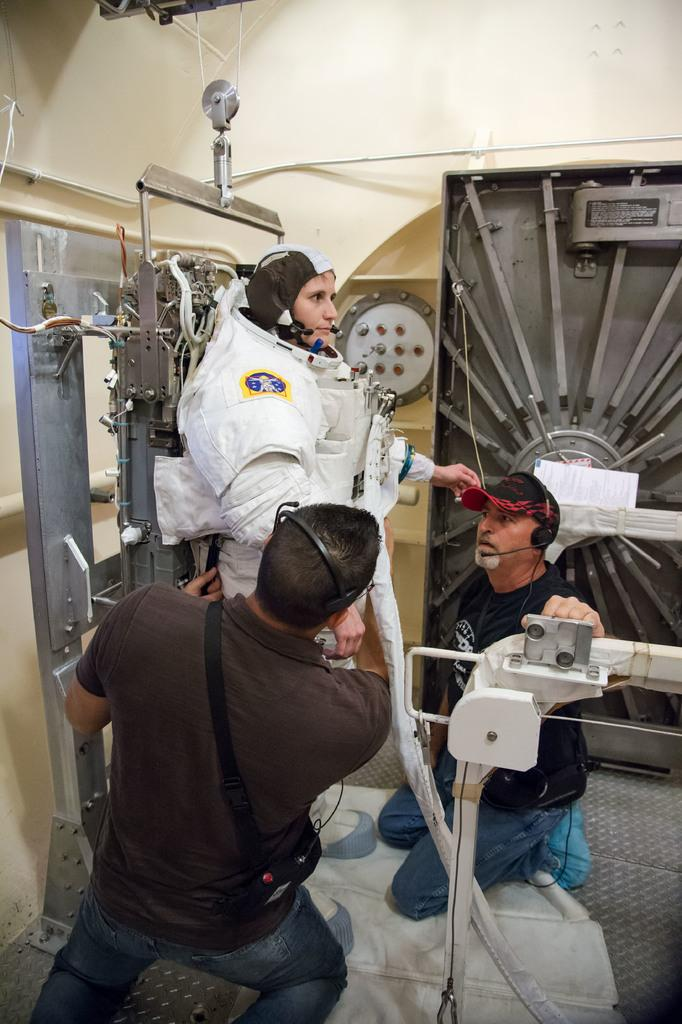How many people are in the image? There are three persons in the image. What is the person in the middle wearing? The person in the middle is wearing an astronaut suit. What else can be seen in the image besides the people? There is equipment visible in the image. What is in the background of the image? There is a wall in the background of the image. What type of bed can be seen in the image? There is no bed present in the image. What ingredients are used to make the stew in the image? There is no stew present in the image. 